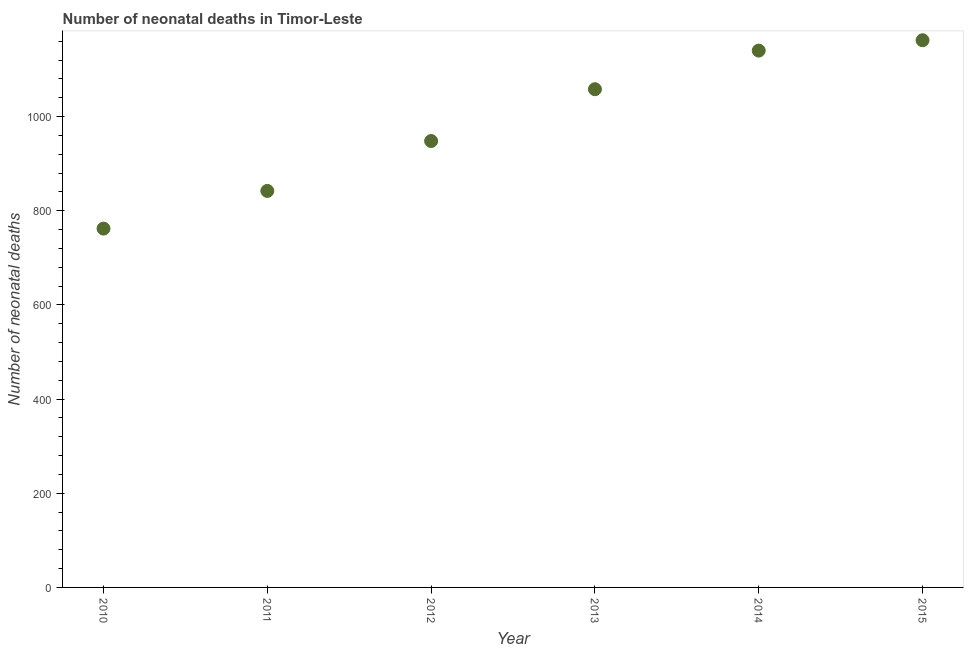What is the number of neonatal deaths in 2015?
Keep it short and to the point. 1162. Across all years, what is the maximum number of neonatal deaths?
Give a very brief answer. 1162. Across all years, what is the minimum number of neonatal deaths?
Offer a very short reply. 762. In which year was the number of neonatal deaths maximum?
Offer a very short reply. 2015. In which year was the number of neonatal deaths minimum?
Make the answer very short. 2010. What is the sum of the number of neonatal deaths?
Give a very brief answer. 5912. What is the difference between the number of neonatal deaths in 2010 and 2012?
Your answer should be compact. -186. What is the average number of neonatal deaths per year?
Offer a terse response. 985.33. What is the median number of neonatal deaths?
Your answer should be compact. 1003. Do a majority of the years between 2015 and 2014 (inclusive) have number of neonatal deaths greater than 960 ?
Keep it short and to the point. No. What is the ratio of the number of neonatal deaths in 2010 to that in 2014?
Provide a succinct answer. 0.67. Is the number of neonatal deaths in 2014 less than that in 2015?
Offer a terse response. Yes. What is the difference between the highest and the lowest number of neonatal deaths?
Offer a terse response. 400. In how many years, is the number of neonatal deaths greater than the average number of neonatal deaths taken over all years?
Provide a succinct answer. 3. Does the number of neonatal deaths monotonically increase over the years?
Give a very brief answer. Yes. How many years are there in the graph?
Ensure brevity in your answer.  6. What is the difference between two consecutive major ticks on the Y-axis?
Ensure brevity in your answer.  200. Are the values on the major ticks of Y-axis written in scientific E-notation?
Offer a terse response. No. What is the title of the graph?
Provide a succinct answer. Number of neonatal deaths in Timor-Leste. What is the label or title of the Y-axis?
Offer a very short reply. Number of neonatal deaths. What is the Number of neonatal deaths in 2010?
Keep it short and to the point. 762. What is the Number of neonatal deaths in 2011?
Offer a very short reply. 842. What is the Number of neonatal deaths in 2012?
Offer a terse response. 948. What is the Number of neonatal deaths in 2013?
Provide a short and direct response. 1058. What is the Number of neonatal deaths in 2014?
Offer a very short reply. 1140. What is the Number of neonatal deaths in 2015?
Your answer should be compact. 1162. What is the difference between the Number of neonatal deaths in 2010 and 2011?
Your response must be concise. -80. What is the difference between the Number of neonatal deaths in 2010 and 2012?
Make the answer very short. -186. What is the difference between the Number of neonatal deaths in 2010 and 2013?
Keep it short and to the point. -296. What is the difference between the Number of neonatal deaths in 2010 and 2014?
Offer a terse response. -378. What is the difference between the Number of neonatal deaths in 2010 and 2015?
Your response must be concise. -400. What is the difference between the Number of neonatal deaths in 2011 and 2012?
Your answer should be very brief. -106. What is the difference between the Number of neonatal deaths in 2011 and 2013?
Make the answer very short. -216. What is the difference between the Number of neonatal deaths in 2011 and 2014?
Make the answer very short. -298. What is the difference between the Number of neonatal deaths in 2011 and 2015?
Offer a very short reply. -320. What is the difference between the Number of neonatal deaths in 2012 and 2013?
Make the answer very short. -110. What is the difference between the Number of neonatal deaths in 2012 and 2014?
Your response must be concise. -192. What is the difference between the Number of neonatal deaths in 2012 and 2015?
Provide a succinct answer. -214. What is the difference between the Number of neonatal deaths in 2013 and 2014?
Offer a terse response. -82. What is the difference between the Number of neonatal deaths in 2013 and 2015?
Your response must be concise. -104. What is the difference between the Number of neonatal deaths in 2014 and 2015?
Offer a terse response. -22. What is the ratio of the Number of neonatal deaths in 2010 to that in 2011?
Give a very brief answer. 0.91. What is the ratio of the Number of neonatal deaths in 2010 to that in 2012?
Offer a terse response. 0.8. What is the ratio of the Number of neonatal deaths in 2010 to that in 2013?
Make the answer very short. 0.72. What is the ratio of the Number of neonatal deaths in 2010 to that in 2014?
Your response must be concise. 0.67. What is the ratio of the Number of neonatal deaths in 2010 to that in 2015?
Your answer should be compact. 0.66. What is the ratio of the Number of neonatal deaths in 2011 to that in 2012?
Offer a very short reply. 0.89. What is the ratio of the Number of neonatal deaths in 2011 to that in 2013?
Provide a short and direct response. 0.8. What is the ratio of the Number of neonatal deaths in 2011 to that in 2014?
Offer a very short reply. 0.74. What is the ratio of the Number of neonatal deaths in 2011 to that in 2015?
Ensure brevity in your answer.  0.72. What is the ratio of the Number of neonatal deaths in 2012 to that in 2013?
Your answer should be compact. 0.9. What is the ratio of the Number of neonatal deaths in 2012 to that in 2014?
Provide a short and direct response. 0.83. What is the ratio of the Number of neonatal deaths in 2012 to that in 2015?
Your answer should be compact. 0.82. What is the ratio of the Number of neonatal deaths in 2013 to that in 2014?
Ensure brevity in your answer.  0.93. What is the ratio of the Number of neonatal deaths in 2013 to that in 2015?
Give a very brief answer. 0.91. What is the ratio of the Number of neonatal deaths in 2014 to that in 2015?
Provide a short and direct response. 0.98. 